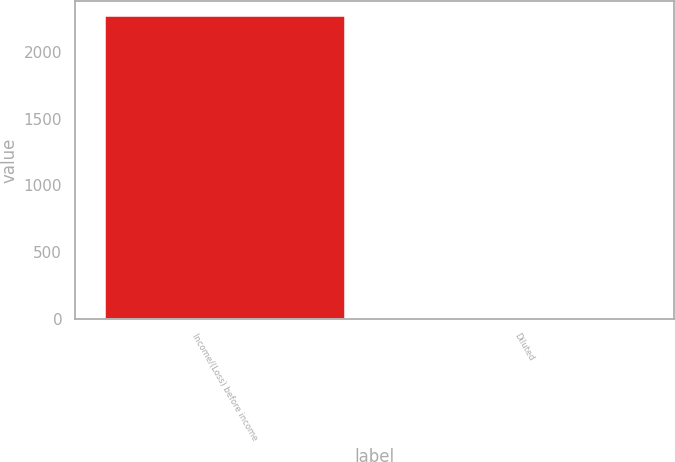Convert chart. <chart><loc_0><loc_0><loc_500><loc_500><bar_chart><fcel>Income/(Loss) before income<fcel>Diluted<nl><fcel>2266<fcel>0.51<nl></chart> 